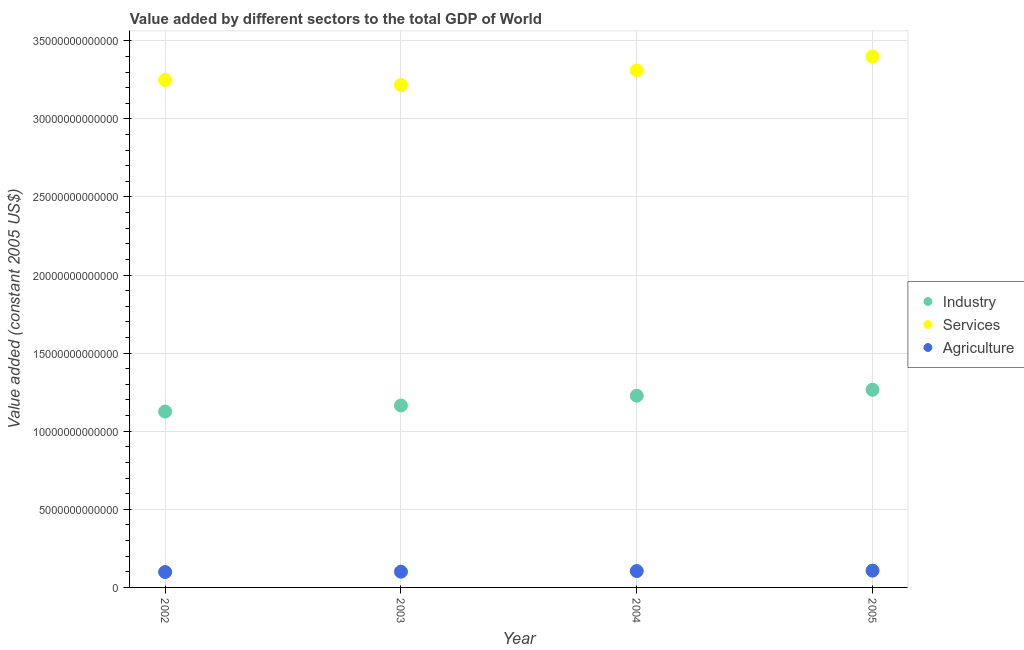How many different coloured dotlines are there?
Your answer should be very brief. 3. Is the number of dotlines equal to the number of legend labels?
Offer a very short reply. Yes. What is the value added by agricultural sector in 2004?
Give a very brief answer. 1.05e+12. Across all years, what is the maximum value added by services?
Make the answer very short. 3.40e+13. Across all years, what is the minimum value added by services?
Keep it short and to the point. 3.22e+13. In which year was the value added by agricultural sector maximum?
Provide a short and direct response. 2005. In which year was the value added by agricultural sector minimum?
Keep it short and to the point. 2002. What is the total value added by services in the graph?
Ensure brevity in your answer.  1.32e+14. What is the difference between the value added by agricultural sector in 2004 and that in 2005?
Ensure brevity in your answer.  -2.64e+1. What is the difference between the value added by agricultural sector in 2003 and the value added by industrial sector in 2005?
Offer a very short reply. -1.16e+13. What is the average value added by services per year?
Offer a terse response. 3.29e+13. In the year 2002, what is the difference between the value added by industrial sector and value added by services?
Give a very brief answer. -2.12e+13. What is the ratio of the value added by services in 2002 to that in 2003?
Keep it short and to the point. 1.01. Is the value added by services in 2003 less than that in 2004?
Offer a terse response. Yes. Is the difference between the value added by agricultural sector in 2002 and 2004 greater than the difference between the value added by industrial sector in 2002 and 2004?
Give a very brief answer. Yes. What is the difference between the highest and the second highest value added by industrial sector?
Make the answer very short. 3.83e+11. What is the difference between the highest and the lowest value added by services?
Ensure brevity in your answer.  1.82e+12. In how many years, is the value added by agricultural sector greater than the average value added by agricultural sector taken over all years?
Provide a short and direct response. 2. Is the sum of the value added by services in 2002 and 2004 greater than the maximum value added by agricultural sector across all years?
Offer a very short reply. Yes. Is it the case that in every year, the sum of the value added by industrial sector and value added by services is greater than the value added by agricultural sector?
Your response must be concise. Yes. Does the value added by industrial sector monotonically increase over the years?
Provide a succinct answer. Yes. How many years are there in the graph?
Provide a succinct answer. 4. What is the difference between two consecutive major ticks on the Y-axis?
Offer a terse response. 5.00e+12. Does the graph contain any zero values?
Your answer should be very brief. No. How many legend labels are there?
Give a very brief answer. 3. How are the legend labels stacked?
Your answer should be compact. Vertical. What is the title of the graph?
Offer a terse response. Value added by different sectors to the total GDP of World. What is the label or title of the Y-axis?
Your answer should be very brief. Value added (constant 2005 US$). What is the Value added (constant 2005 US$) in Industry in 2002?
Ensure brevity in your answer.  1.13e+13. What is the Value added (constant 2005 US$) in Services in 2002?
Provide a short and direct response. 3.25e+13. What is the Value added (constant 2005 US$) in Agriculture in 2002?
Your answer should be compact. 9.86e+11. What is the Value added (constant 2005 US$) in Industry in 2003?
Give a very brief answer. 1.16e+13. What is the Value added (constant 2005 US$) in Services in 2003?
Your answer should be compact. 3.22e+13. What is the Value added (constant 2005 US$) of Agriculture in 2003?
Ensure brevity in your answer.  1.01e+12. What is the Value added (constant 2005 US$) in Industry in 2004?
Ensure brevity in your answer.  1.23e+13. What is the Value added (constant 2005 US$) of Services in 2004?
Provide a short and direct response. 3.31e+13. What is the Value added (constant 2005 US$) of Agriculture in 2004?
Make the answer very short. 1.05e+12. What is the Value added (constant 2005 US$) in Industry in 2005?
Give a very brief answer. 1.27e+13. What is the Value added (constant 2005 US$) of Services in 2005?
Offer a terse response. 3.40e+13. What is the Value added (constant 2005 US$) in Agriculture in 2005?
Make the answer very short. 1.07e+12. Across all years, what is the maximum Value added (constant 2005 US$) in Industry?
Provide a succinct answer. 1.27e+13. Across all years, what is the maximum Value added (constant 2005 US$) of Services?
Your answer should be very brief. 3.40e+13. Across all years, what is the maximum Value added (constant 2005 US$) in Agriculture?
Provide a short and direct response. 1.07e+12. Across all years, what is the minimum Value added (constant 2005 US$) in Industry?
Provide a succinct answer. 1.13e+13. Across all years, what is the minimum Value added (constant 2005 US$) of Services?
Provide a succinct answer. 3.22e+13. Across all years, what is the minimum Value added (constant 2005 US$) in Agriculture?
Give a very brief answer. 9.86e+11. What is the total Value added (constant 2005 US$) in Industry in the graph?
Offer a very short reply. 4.78e+13. What is the total Value added (constant 2005 US$) of Services in the graph?
Your answer should be very brief. 1.32e+14. What is the total Value added (constant 2005 US$) in Agriculture in the graph?
Make the answer very short. 4.11e+12. What is the difference between the Value added (constant 2005 US$) in Industry in 2002 and that in 2003?
Your answer should be very brief. -3.85e+11. What is the difference between the Value added (constant 2005 US$) in Services in 2002 and that in 2003?
Offer a terse response. 3.24e+11. What is the difference between the Value added (constant 2005 US$) in Agriculture in 2002 and that in 2003?
Offer a terse response. -2.14e+1. What is the difference between the Value added (constant 2005 US$) in Industry in 2002 and that in 2004?
Make the answer very short. -1.01e+12. What is the difference between the Value added (constant 2005 US$) of Services in 2002 and that in 2004?
Offer a terse response. -6.14e+11. What is the difference between the Value added (constant 2005 US$) in Agriculture in 2002 and that in 2004?
Provide a succinct answer. -6.21e+1. What is the difference between the Value added (constant 2005 US$) in Industry in 2002 and that in 2005?
Your response must be concise. -1.39e+12. What is the difference between the Value added (constant 2005 US$) in Services in 2002 and that in 2005?
Make the answer very short. -1.50e+12. What is the difference between the Value added (constant 2005 US$) of Agriculture in 2002 and that in 2005?
Provide a succinct answer. -8.85e+1. What is the difference between the Value added (constant 2005 US$) in Industry in 2003 and that in 2004?
Provide a short and direct response. -6.26e+11. What is the difference between the Value added (constant 2005 US$) in Services in 2003 and that in 2004?
Give a very brief answer. -9.37e+11. What is the difference between the Value added (constant 2005 US$) in Agriculture in 2003 and that in 2004?
Your response must be concise. -4.07e+1. What is the difference between the Value added (constant 2005 US$) in Industry in 2003 and that in 2005?
Your answer should be very brief. -1.01e+12. What is the difference between the Value added (constant 2005 US$) in Services in 2003 and that in 2005?
Give a very brief answer. -1.82e+12. What is the difference between the Value added (constant 2005 US$) of Agriculture in 2003 and that in 2005?
Give a very brief answer. -6.71e+1. What is the difference between the Value added (constant 2005 US$) in Industry in 2004 and that in 2005?
Your answer should be very brief. -3.83e+11. What is the difference between the Value added (constant 2005 US$) in Services in 2004 and that in 2005?
Give a very brief answer. -8.86e+11. What is the difference between the Value added (constant 2005 US$) in Agriculture in 2004 and that in 2005?
Your response must be concise. -2.64e+1. What is the difference between the Value added (constant 2005 US$) of Industry in 2002 and the Value added (constant 2005 US$) of Services in 2003?
Give a very brief answer. -2.09e+13. What is the difference between the Value added (constant 2005 US$) of Industry in 2002 and the Value added (constant 2005 US$) of Agriculture in 2003?
Keep it short and to the point. 1.03e+13. What is the difference between the Value added (constant 2005 US$) in Services in 2002 and the Value added (constant 2005 US$) in Agriculture in 2003?
Ensure brevity in your answer.  3.15e+13. What is the difference between the Value added (constant 2005 US$) of Industry in 2002 and the Value added (constant 2005 US$) of Services in 2004?
Offer a very short reply. -2.18e+13. What is the difference between the Value added (constant 2005 US$) in Industry in 2002 and the Value added (constant 2005 US$) in Agriculture in 2004?
Offer a terse response. 1.02e+13. What is the difference between the Value added (constant 2005 US$) in Services in 2002 and the Value added (constant 2005 US$) in Agriculture in 2004?
Provide a succinct answer. 3.14e+13. What is the difference between the Value added (constant 2005 US$) of Industry in 2002 and the Value added (constant 2005 US$) of Services in 2005?
Offer a very short reply. -2.27e+13. What is the difference between the Value added (constant 2005 US$) of Industry in 2002 and the Value added (constant 2005 US$) of Agriculture in 2005?
Offer a very short reply. 1.02e+13. What is the difference between the Value added (constant 2005 US$) in Services in 2002 and the Value added (constant 2005 US$) in Agriculture in 2005?
Give a very brief answer. 3.14e+13. What is the difference between the Value added (constant 2005 US$) in Industry in 2003 and the Value added (constant 2005 US$) in Services in 2004?
Provide a short and direct response. -2.15e+13. What is the difference between the Value added (constant 2005 US$) in Industry in 2003 and the Value added (constant 2005 US$) in Agriculture in 2004?
Your answer should be very brief. 1.06e+13. What is the difference between the Value added (constant 2005 US$) of Services in 2003 and the Value added (constant 2005 US$) of Agriculture in 2004?
Your response must be concise. 3.11e+13. What is the difference between the Value added (constant 2005 US$) of Industry in 2003 and the Value added (constant 2005 US$) of Services in 2005?
Ensure brevity in your answer.  -2.23e+13. What is the difference between the Value added (constant 2005 US$) in Industry in 2003 and the Value added (constant 2005 US$) in Agriculture in 2005?
Provide a short and direct response. 1.06e+13. What is the difference between the Value added (constant 2005 US$) of Services in 2003 and the Value added (constant 2005 US$) of Agriculture in 2005?
Give a very brief answer. 3.11e+13. What is the difference between the Value added (constant 2005 US$) in Industry in 2004 and the Value added (constant 2005 US$) in Services in 2005?
Give a very brief answer. -2.17e+13. What is the difference between the Value added (constant 2005 US$) of Industry in 2004 and the Value added (constant 2005 US$) of Agriculture in 2005?
Your answer should be compact. 1.12e+13. What is the difference between the Value added (constant 2005 US$) in Services in 2004 and the Value added (constant 2005 US$) in Agriculture in 2005?
Keep it short and to the point. 3.20e+13. What is the average Value added (constant 2005 US$) of Industry per year?
Your answer should be compact. 1.20e+13. What is the average Value added (constant 2005 US$) of Services per year?
Ensure brevity in your answer.  3.29e+13. What is the average Value added (constant 2005 US$) in Agriculture per year?
Provide a succinct answer. 1.03e+12. In the year 2002, what is the difference between the Value added (constant 2005 US$) of Industry and Value added (constant 2005 US$) of Services?
Make the answer very short. -2.12e+13. In the year 2002, what is the difference between the Value added (constant 2005 US$) in Industry and Value added (constant 2005 US$) in Agriculture?
Make the answer very short. 1.03e+13. In the year 2002, what is the difference between the Value added (constant 2005 US$) in Services and Value added (constant 2005 US$) in Agriculture?
Provide a succinct answer. 3.15e+13. In the year 2003, what is the difference between the Value added (constant 2005 US$) in Industry and Value added (constant 2005 US$) in Services?
Provide a short and direct response. -2.05e+13. In the year 2003, what is the difference between the Value added (constant 2005 US$) of Industry and Value added (constant 2005 US$) of Agriculture?
Provide a short and direct response. 1.06e+13. In the year 2003, what is the difference between the Value added (constant 2005 US$) of Services and Value added (constant 2005 US$) of Agriculture?
Your answer should be compact. 3.12e+13. In the year 2004, what is the difference between the Value added (constant 2005 US$) in Industry and Value added (constant 2005 US$) in Services?
Offer a very short reply. -2.08e+13. In the year 2004, what is the difference between the Value added (constant 2005 US$) in Industry and Value added (constant 2005 US$) in Agriculture?
Offer a very short reply. 1.12e+13. In the year 2004, what is the difference between the Value added (constant 2005 US$) of Services and Value added (constant 2005 US$) of Agriculture?
Give a very brief answer. 3.21e+13. In the year 2005, what is the difference between the Value added (constant 2005 US$) of Industry and Value added (constant 2005 US$) of Services?
Give a very brief answer. -2.13e+13. In the year 2005, what is the difference between the Value added (constant 2005 US$) of Industry and Value added (constant 2005 US$) of Agriculture?
Offer a terse response. 1.16e+13. In the year 2005, what is the difference between the Value added (constant 2005 US$) of Services and Value added (constant 2005 US$) of Agriculture?
Keep it short and to the point. 3.29e+13. What is the ratio of the Value added (constant 2005 US$) in Agriculture in 2002 to that in 2003?
Provide a succinct answer. 0.98. What is the ratio of the Value added (constant 2005 US$) of Industry in 2002 to that in 2004?
Provide a short and direct response. 0.92. What is the ratio of the Value added (constant 2005 US$) in Services in 2002 to that in 2004?
Provide a short and direct response. 0.98. What is the ratio of the Value added (constant 2005 US$) in Agriculture in 2002 to that in 2004?
Offer a terse response. 0.94. What is the ratio of the Value added (constant 2005 US$) in Industry in 2002 to that in 2005?
Your answer should be very brief. 0.89. What is the ratio of the Value added (constant 2005 US$) in Services in 2002 to that in 2005?
Ensure brevity in your answer.  0.96. What is the ratio of the Value added (constant 2005 US$) of Agriculture in 2002 to that in 2005?
Ensure brevity in your answer.  0.92. What is the ratio of the Value added (constant 2005 US$) of Industry in 2003 to that in 2004?
Your answer should be compact. 0.95. What is the ratio of the Value added (constant 2005 US$) in Services in 2003 to that in 2004?
Give a very brief answer. 0.97. What is the ratio of the Value added (constant 2005 US$) in Agriculture in 2003 to that in 2004?
Keep it short and to the point. 0.96. What is the ratio of the Value added (constant 2005 US$) of Industry in 2003 to that in 2005?
Your response must be concise. 0.92. What is the ratio of the Value added (constant 2005 US$) in Services in 2003 to that in 2005?
Keep it short and to the point. 0.95. What is the ratio of the Value added (constant 2005 US$) in Agriculture in 2003 to that in 2005?
Provide a short and direct response. 0.94. What is the ratio of the Value added (constant 2005 US$) in Industry in 2004 to that in 2005?
Your answer should be compact. 0.97. What is the ratio of the Value added (constant 2005 US$) in Services in 2004 to that in 2005?
Your response must be concise. 0.97. What is the ratio of the Value added (constant 2005 US$) of Agriculture in 2004 to that in 2005?
Provide a short and direct response. 0.98. What is the difference between the highest and the second highest Value added (constant 2005 US$) in Industry?
Ensure brevity in your answer.  3.83e+11. What is the difference between the highest and the second highest Value added (constant 2005 US$) in Services?
Your response must be concise. 8.86e+11. What is the difference between the highest and the second highest Value added (constant 2005 US$) of Agriculture?
Your answer should be compact. 2.64e+1. What is the difference between the highest and the lowest Value added (constant 2005 US$) in Industry?
Offer a terse response. 1.39e+12. What is the difference between the highest and the lowest Value added (constant 2005 US$) in Services?
Keep it short and to the point. 1.82e+12. What is the difference between the highest and the lowest Value added (constant 2005 US$) in Agriculture?
Offer a terse response. 8.85e+1. 